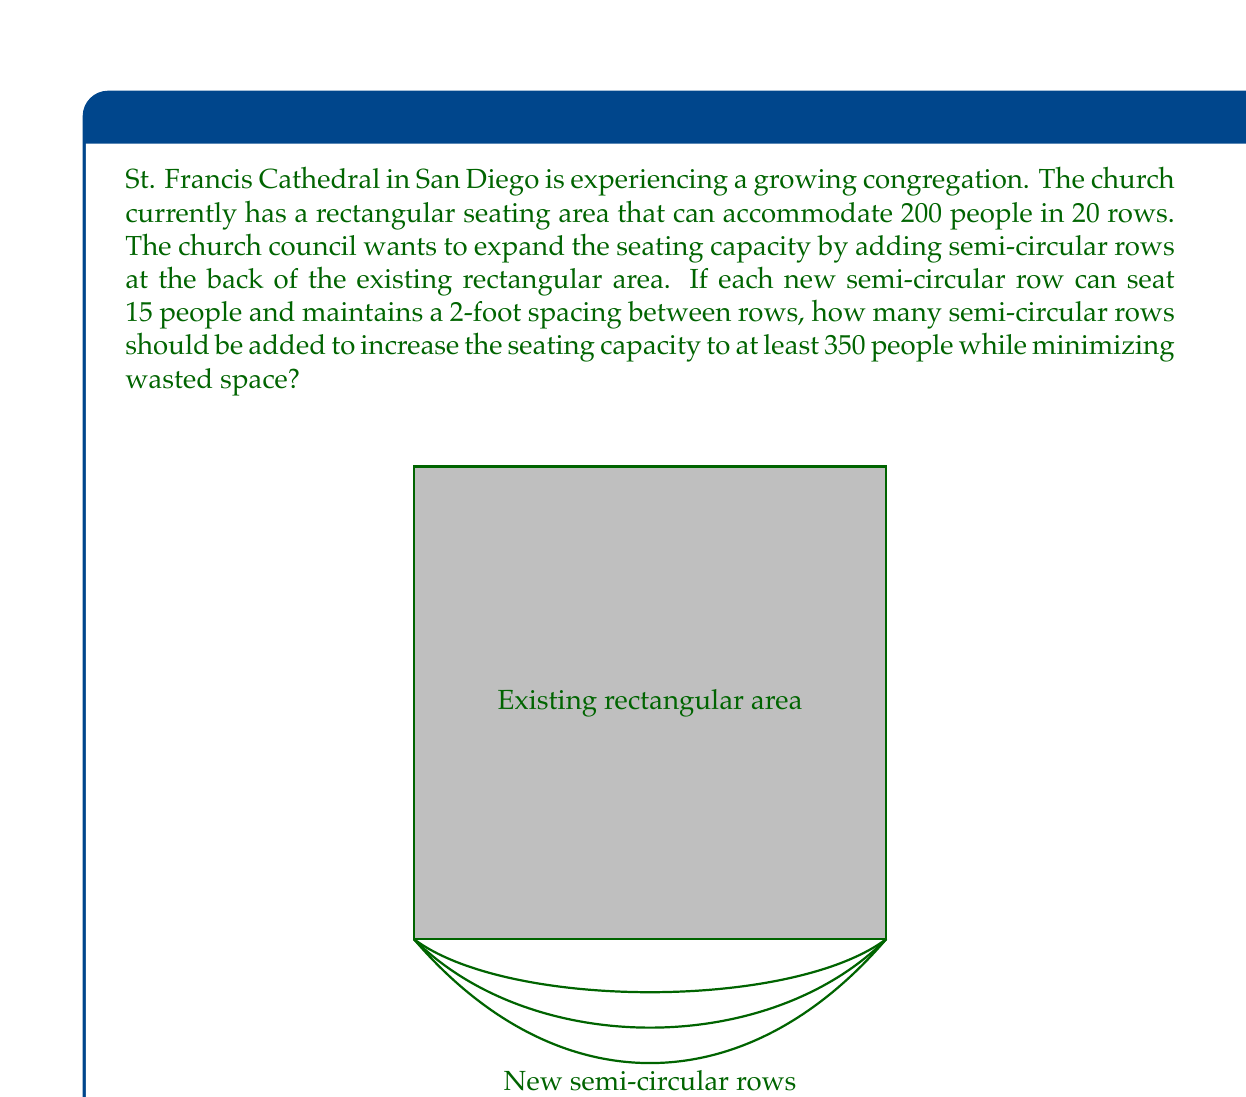Could you help me with this problem? Let's approach this problem step-by-step:

1) First, we need to calculate how many additional seats are needed:
   $$350 - 200 = 150$$ additional seats are required.

2) Each semi-circular row can seat 15 people. Let's define $x$ as the number of semi-circular rows to be added.

3) We can set up an inequality to represent the seating requirement:
   $$200 + 15x \geq 350$$

4) Solving for $x$:
   $$15x \geq 150$$
   $$x \geq 10$$

5) Since we can only add whole rows, we need to round up to the nearest integer. Therefore, we need at least 10 semi-circular rows.

6) To check if 10 rows are sufficient:
   $$200 + (15 \times 10) = 350$$

7) This exactly meets our requirement of 350 seats, minimizing wasted space.

8) We can confirm that 11 rows would exceed our needs:
   $$200 + (15 \times 11) = 365$$
   This would create 15 unused seats, which is less efficient.

Therefore, adding 10 semi-circular rows is the most efficient solution to reach the desired seating capacity while minimizing wasted space.
Answer: 10 semi-circular rows 